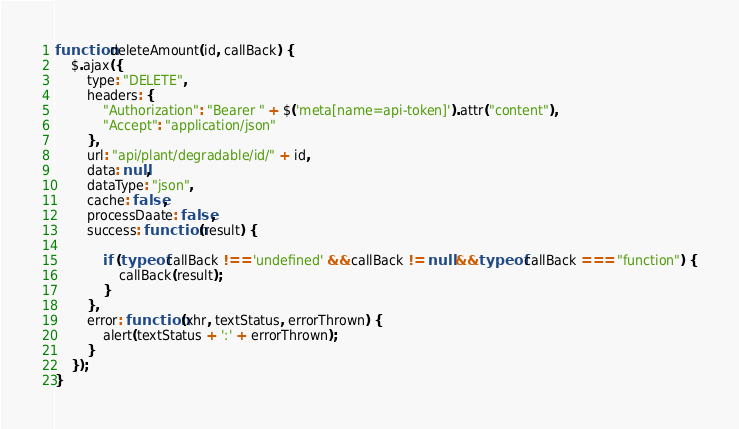Convert code to text. <code><loc_0><loc_0><loc_500><loc_500><_JavaScript_>function deleteAmount(id, callBack) {
    $.ajax({
        type: "DELETE",
        headers: {
            "Authorization": "Bearer " + $('meta[name=api-token]').attr("content"),
            "Accept": "application/json"
        },
        url: "api/plant/degradable/id/" + id,
        data: null,
        dataType: "json",
        cache: false,
        processDaate: false,
        success: function (result) {

            if (typeof callBack !== 'undefined' && callBack != null && typeof callBack === "function") {
                callBack(result);
            }
        },
        error: function (xhr, textStatus, errorThrown) {
            alert(textStatus + ':' + errorThrown);
        }
    });
}</code> 